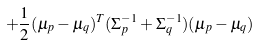<formula> <loc_0><loc_0><loc_500><loc_500>+ \frac { 1 } { 2 } ( \mu _ { p } - \mu _ { q } ) ^ { T } ( \Sigma ^ { - 1 } _ { p } + \Sigma ^ { - 1 } _ { q } ) ( \mu _ { p } - \mu _ { q } )</formula> 